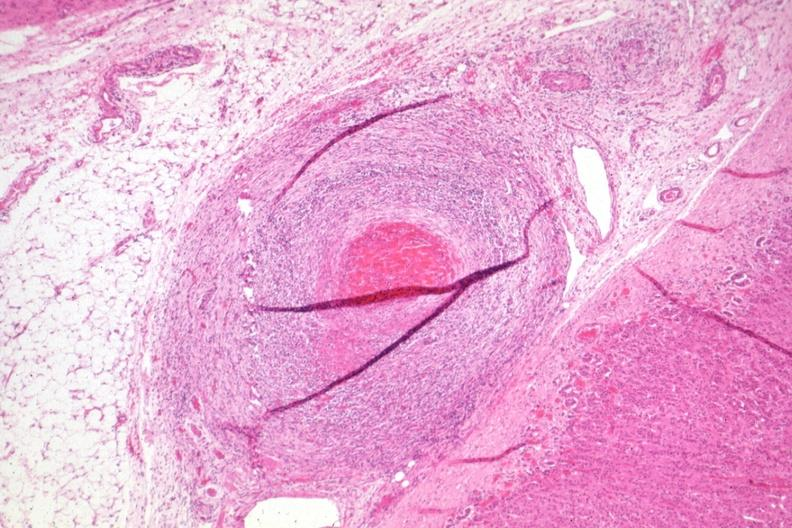s muscle atrophy present?
Answer the question using a single word or phrase. No 